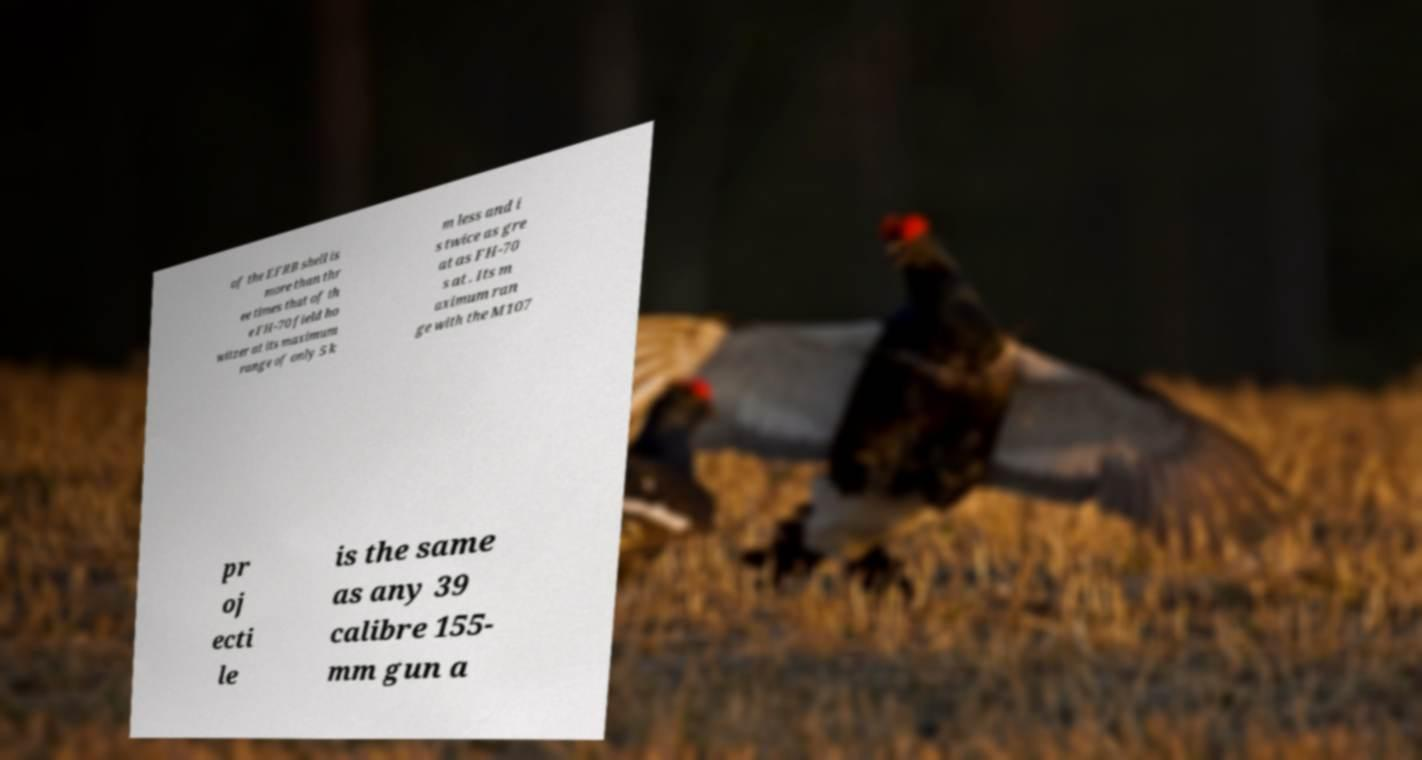Could you extract and type out the text from this image? of the EFRB shell is more than thr ee times that of th e FH-70 field ho witzer at its maximum range of only 5 k m less and i s twice as gre at as FH-70 s at . Its m aximum ran ge with the M107 pr oj ecti le is the same as any 39 calibre 155- mm gun a 